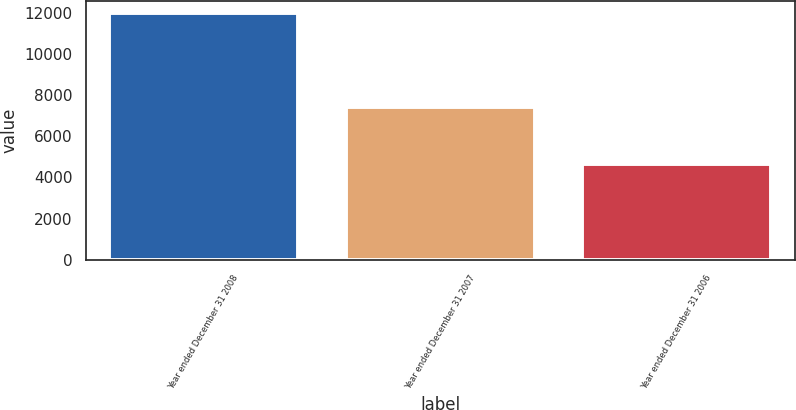Convert chart to OTSL. <chart><loc_0><loc_0><loc_500><loc_500><bar_chart><fcel>Year ended December 31 2008<fcel>Year ended December 31 2007<fcel>Year ended December 31 2006<nl><fcel>11976<fcel>7446<fcel>4670<nl></chart> 